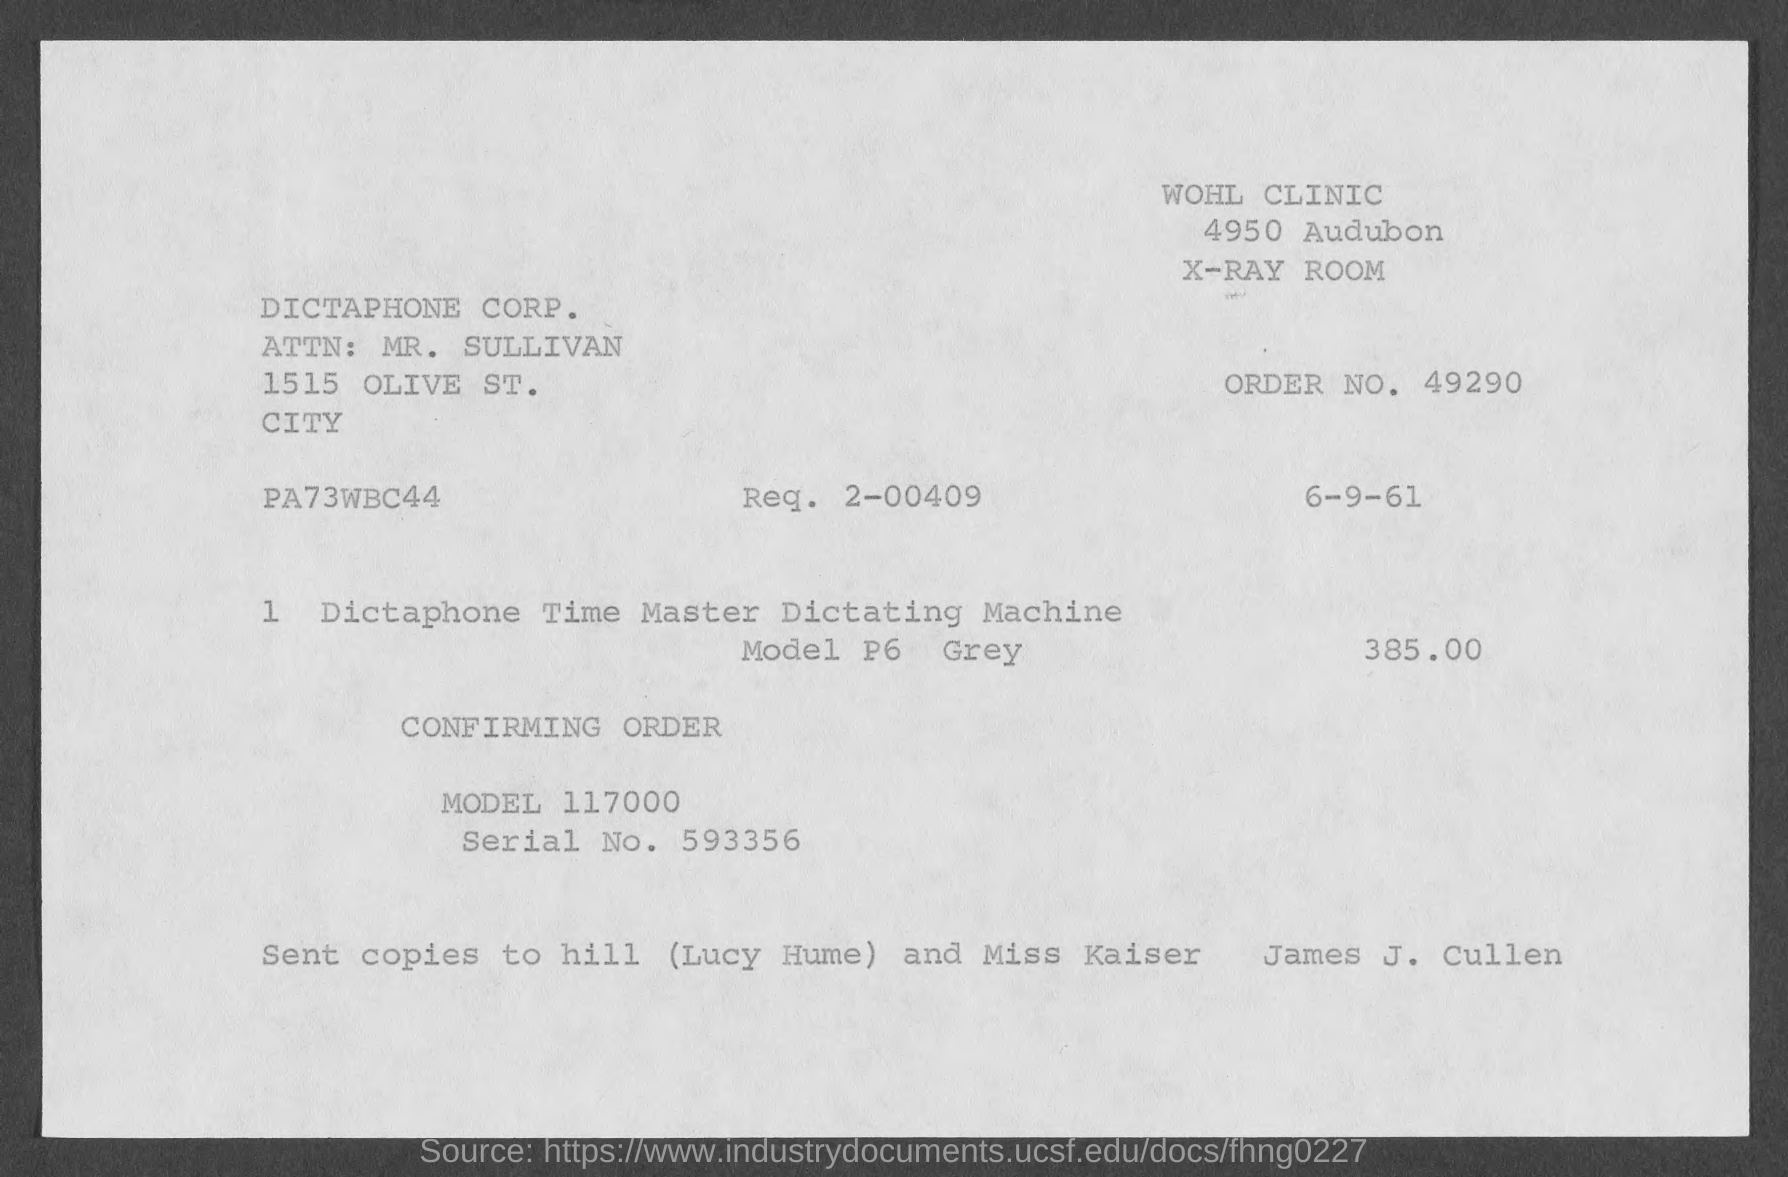Indicate a few pertinent items in this graphic. The model number is 117000... What is the request number 2-00409...? What is the serial number?" is a question. It is asking for information about a serial number that is associated with an object or a piece of equipment. The serial number being referred to is 593356... The person's name is Mr. Sullivan. Order number 49290... has been requested. 